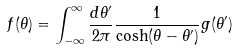Convert formula to latex. <formula><loc_0><loc_0><loc_500><loc_500>f ( \theta ) = \int _ { - \infty } ^ { \infty } \frac { d \theta ^ { \prime } } { 2 \pi } \frac { 1 } { \cosh ( \theta - \theta ^ { \prime } ) } g ( \theta ^ { \prime } )</formula> 